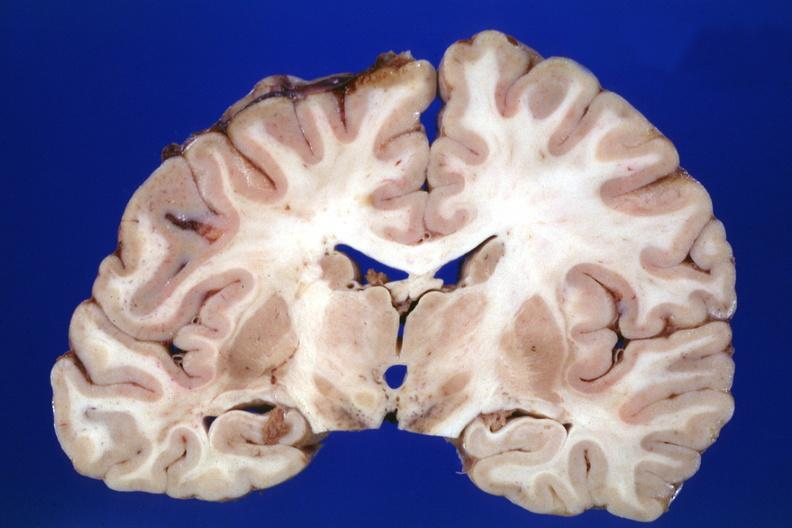what does this image show?
Answer the question using a single word or phrase. Fixed tissue coronal section cerebral hemispheres case of diabetic cardiomyopathy with history of left hemisphere stroke slides shows no lesion the lesion was in the pons 